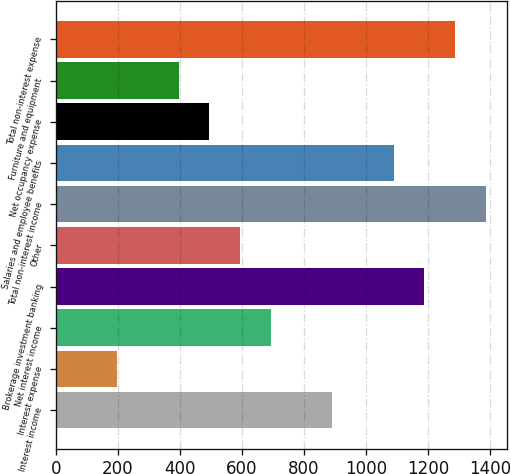Convert chart to OTSL. <chart><loc_0><loc_0><loc_500><loc_500><bar_chart><fcel>Interest income<fcel>Interest expense<fcel>Net interest income<fcel>Brokerage investment banking<fcel>Other<fcel>Total non-interest income<fcel>Salaries and employee benefits<fcel>Net occupancy expense<fcel>Furniture and equipment<fcel>Total non-interest expense<nl><fcel>891.04<fcel>198.04<fcel>693.04<fcel>1188.04<fcel>594.04<fcel>1386.04<fcel>1089.04<fcel>495.04<fcel>396.04<fcel>1287.04<nl></chart> 